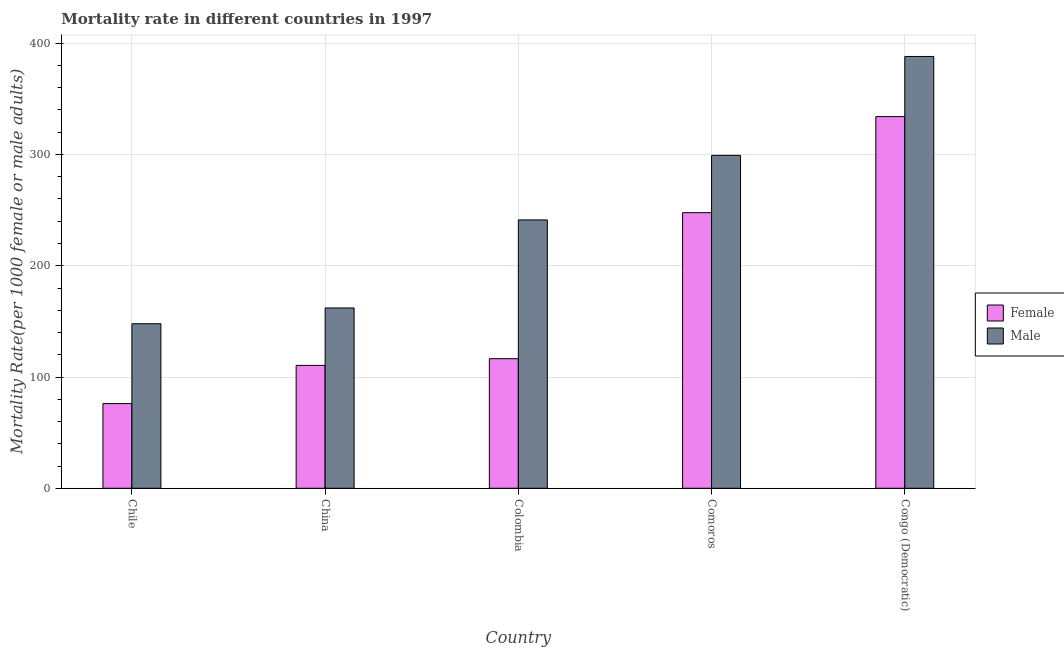How many groups of bars are there?
Give a very brief answer. 5. Are the number of bars on each tick of the X-axis equal?
Your answer should be compact. Yes. How many bars are there on the 2nd tick from the left?
Your answer should be compact. 2. How many bars are there on the 2nd tick from the right?
Offer a very short reply. 2. What is the label of the 5th group of bars from the left?
Your answer should be compact. Congo (Democratic). What is the female mortality rate in Congo (Democratic)?
Give a very brief answer. 334.06. Across all countries, what is the maximum male mortality rate?
Ensure brevity in your answer.  388.1. Across all countries, what is the minimum male mortality rate?
Offer a very short reply. 147.9. In which country was the male mortality rate maximum?
Ensure brevity in your answer.  Congo (Democratic). What is the total female mortality rate in the graph?
Your answer should be very brief. 884.8. What is the difference between the female mortality rate in Chile and that in Congo (Democratic)?
Offer a very short reply. -257.93. What is the difference between the male mortality rate in China and the female mortality rate in Congo (Democratic)?
Your answer should be compact. -172. What is the average male mortality rate per country?
Your response must be concise. 247.7. What is the difference between the female mortality rate and male mortality rate in Congo (Democratic)?
Keep it short and to the point. -54.04. What is the ratio of the male mortality rate in China to that in Colombia?
Make the answer very short. 0.67. What is the difference between the highest and the second highest female mortality rate?
Your answer should be very brief. 86.36. What is the difference between the highest and the lowest male mortality rate?
Provide a succinct answer. 240.2. Is the sum of the female mortality rate in China and Comoros greater than the maximum male mortality rate across all countries?
Make the answer very short. No. What does the 2nd bar from the right in Colombia represents?
Give a very brief answer. Female. How many countries are there in the graph?
Make the answer very short. 5. What is the difference between two consecutive major ticks on the Y-axis?
Offer a terse response. 100. Does the graph contain grids?
Offer a terse response. Yes. What is the title of the graph?
Keep it short and to the point. Mortality rate in different countries in 1997. What is the label or title of the X-axis?
Give a very brief answer. Country. What is the label or title of the Y-axis?
Keep it short and to the point. Mortality Rate(per 1000 female or male adults). What is the Mortality Rate(per 1000 female or male adults) of Female in Chile?
Provide a succinct answer. 76.13. What is the Mortality Rate(per 1000 female or male adults) of Male in Chile?
Your answer should be compact. 147.9. What is the Mortality Rate(per 1000 female or male adults) in Female in China?
Ensure brevity in your answer.  110.46. What is the Mortality Rate(per 1000 female or male adults) in Male in China?
Make the answer very short. 162.06. What is the Mortality Rate(per 1000 female or male adults) in Female in Colombia?
Provide a short and direct response. 116.47. What is the Mortality Rate(per 1000 female or male adults) of Male in Colombia?
Your answer should be compact. 241.19. What is the Mortality Rate(per 1000 female or male adults) of Female in Comoros?
Keep it short and to the point. 247.69. What is the Mortality Rate(per 1000 female or male adults) of Male in Comoros?
Your answer should be compact. 299.23. What is the Mortality Rate(per 1000 female or male adults) of Female in Congo (Democratic)?
Provide a succinct answer. 334.06. What is the Mortality Rate(per 1000 female or male adults) of Male in Congo (Democratic)?
Your answer should be very brief. 388.1. Across all countries, what is the maximum Mortality Rate(per 1000 female or male adults) of Female?
Your response must be concise. 334.06. Across all countries, what is the maximum Mortality Rate(per 1000 female or male adults) of Male?
Your answer should be very brief. 388.1. Across all countries, what is the minimum Mortality Rate(per 1000 female or male adults) in Female?
Make the answer very short. 76.13. Across all countries, what is the minimum Mortality Rate(per 1000 female or male adults) of Male?
Ensure brevity in your answer.  147.9. What is the total Mortality Rate(per 1000 female or male adults) in Female in the graph?
Provide a short and direct response. 884.8. What is the total Mortality Rate(per 1000 female or male adults) in Male in the graph?
Make the answer very short. 1238.48. What is the difference between the Mortality Rate(per 1000 female or male adults) in Female in Chile and that in China?
Your answer should be very brief. -34.33. What is the difference between the Mortality Rate(per 1000 female or male adults) in Male in Chile and that in China?
Your response must be concise. -14.16. What is the difference between the Mortality Rate(per 1000 female or male adults) of Female in Chile and that in Colombia?
Ensure brevity in your answer.  -40.34. What is the difference between the Mortality Rate(per 1000 female or male adults) in Male in Chile and that in Colombia?
Give a very brief answer. -93.3. What is the difference between the Mortality Rate(per 1000 female or male adults) of Female in Chile and that in Comoros?
Provide a succinct answer. -171.57. What is the difference between the Mortality Rate(per 1000 female or male adults) of Male in Chile and that in Comoros?
Keep it short and to the point. -151.33. What is the difference between the Mortality Rate(per 1000 female or male adults) of Female in Chile and that in Congo (Democratic)?
Your answer should be very brief. -257.93. What is the difference between the Mortality Rate(per 1000 female or male adults) of Male in Chile and that in Congo (Democratic)?
Ensure brevity in your answer.  -240.2. What is the difference between the Mortality Rate(per 1000 female or male adults) in Female in China and that in Colombia?
Keep it short and to the point. -6.01. What is the difference between the Mortality Rate(per 1000 female or male adults) of Male in China and that in Colombia?
Your answer should be very brief. -79.13. What is the difference between the Mortality Rate(per 1000 female or male adults) of Female in China and that in Comoros?
Keep it short and to the point. -137.24. What is the difference between the Mortality Rate(per 1000 female or male adults) of Male in China and that in Comoros?
Your answer should be compact. -137.16. What is the difference between the Mortality Rate(per 1000 female or male adults) in Female in China and that in Congo (Democratic)?
Give a very brief answer. -223.6. What is the difference between the Mortality Rate(per 1000 female or male adults) of Male in China and that in Congo (Democratic)?
Your response must be concise. -226.04. What is the difference between the Mortality Rate(per 1000 female or male adults) of Female in Colombia and that in Comoros?
Make the answer very short. -131.23. What is the difference between the Mortality Rate(per 1000 female or male adults) of Male in Colombia and that in Comoros?
Ensure brevity in your answer.  -58.03. What is the difference between the Mortality Rate(per 1000 female or male adults) in Female in Colombia and that in Congo (Democratic)?
Keep it short and to the point. -217.59. What is the difference between the Mortality Rate(per 1000 female or male adults) of Male in Colombia and that in Congo (Democratic)?
Your response must be concise. -146.91. What is the difference between the Mortality Rate(per 1000 female or male adults) in Female in Comoros and that in Congo (Democratic)?
Offer a terse response. -86.36. What is the difference between the Mortality Rate(per 1000 female or male adults) of Male in Comoros and that in Congo (Democratic)?
Make the answer very short. -88.88. What is the difference between the Mortality Rate(per 1000 female or male adults) in Female in Chile and the Mortality Rate(per 1000 female or male adults) in Male in China?
Make the answer very short. -85.94. What is the difference between the Mortality Rate(per 1000 female or male adults) of Female in Chile and the Mortality Rate(per 1000 female or male adults) of Male in Colombia?
Make the answer very short. -165.07. What is the difference between the Mortality Rate(per 1000 female or male adults) of Female in Chile and the Mortality Rate(per 1000 female or male adults) of Male in Comoros?
Your answer should be very brief. -223.1. What is the difference between the Mortality Rate(per 1000 female or male adults) in Female in Chile and the Mortality Rate(per 1000 female or male adults) in Male in Congo (Democratic)?
Make the answer very short. -311.97. What is the difference between the Mortality Rate(per 1000 female or male adults) in Female in China and the Mortality Rate(per 1000 female or male adults) in Male in Colombia?
Provide a short and direct response. -130.74. What is the difference between the Mortality Rate(per 1000 female or male adults) in Female in China and the Mortality Rate(per 1000 female or male adults) in Male in Comoros?
Provide a short and direct response. -188.77. What is the difference between the Mortality Rate(per 1000 female or male adults) of Female in China and the Mortality Rate(per 1000 female or male adults) of Male in Congo (Democratic)?
Your response must be concise. -277.64. What is the difference between the Mortality Rate(per 1000 female or male adults) in Female in Colombia and the Mortality Rate(per 1000 female or male adults) in Male in Comoros?
Give a very brief answer. -182.76. What is the difference between the Mortality Rate(per 1000 female or male adults) in Female in Colombia and the Mortality Rate(per 1000 female or male adults) in Male in Congo (Democratic)?
Your answer should be very brief. -271.64. What is the difference between the Mortality Rate(per 1000 female or male adults) in Female in Comoros and the Mortality Rate(per 1000 female or male adults) in Male in Congo (Democratic)?
Provide a succinct answer. -140.41. What is the average Mortality Rate(per 1000 female or male adults) of Female per country?
Provide a succinct answer. 176.96. What is the average Mortality Rate(per 1000 female or male adults) of Male per country?
Make the answer very short. 247.7. What is the difference between the Mortality Rate(per 1000 female or male adults) of Female and Mortality Rate(per 1000 female or male adults) of Male in Chile?
Offer a terse response. -71.77. What is the difference between the Mortality Rate(per 1000 female or male adults) in Female and Mortality Rate(per 1000 female or male adults) in Male in China?
Offer a very short reply. -51.6. What is the difference between the Mortality Rate(per 1000 female or male adults) in Female and Mortality Rate(per 1000 female or male adults) in Male in Colombia?
Give a very brief answer. -124.73. What is the difference between the Mortality Rate(per 1000 female or male adults) in Female and Mortality Rate(per 1000 female or male adults) in Male in Comoros?
Give a very brief answer. -51.53. What is the difference between the Mortality Rate(per 1000 female or male adults) of Female and Mortality Rate(per 1000 female or male adults) of Male in Congo (Democratic)?
Your response must be concise. -54.04. What is the ratio of the Mortality Rate(per 1000 female or male adults) in Female in Chile to that in China?
Make the answer very short. 0.69. What is the ratio of the Mortality Rate(per 1000 female or male adults) of Male in Chile to that in China?
Keep it short and to the point. 0.91. What is the ratio of the Mortality Rate(per 1000 female or male adults) of Female in Chile to that in Colombia?
Keep it short and to the point. 0.65. What is the ratio of the Mortality Rate(per 1000 female or male adults) in Male in Chile to that in Colombia?
Offer a very short reply. 0.61. What is the ratio of the Mortality Rate(per 1000 female or male adults) in Female in Chile to that in Comoros?
Give a very brief answer. 0.31. What is the ratio of the Mortality Rate(per 1000 female or male adults) in Male in Chile to that in Comoros?
Your response must be concise. 0.49. What is the ratio of the Mortality Rate(per 1000 female or male adults) of Female in Chile to that in Congo (Democratic)?
Offer a very short reply. 0.23. What is the ratio of the Mortality Rate(per 1000 female or male adults) of Male in Chile to that in Congo (Democratic)?
Provide a short and direct response. 0.38. What is the ratio of the Mortality Rate(per 1000 female or male adults) of Female in China to that in Colombia?
Offer a terse response. 0.95. What is the ratio of the Mortality Rate(per 1000 female or male adults) of Male in China to that in Colombia?
Ensure brevity in your answer.  0.67. What is the ratio of the Mortality Rate(per 1000 female or male adults) in Female in China to that in Comoros?
Keep it short and to the point. 0.45. What is the ratio of the Mortality Rate(per 1000 female or male adults) in Male in China to that in Comoros?
Your answer should be very brief. 0.54. What is the ratio of the Mortality Rate(per 1000 female or male adults) in Female in China to that in Congo (Democratic)?
Give a very brief answer. 0.33. What is the ratio of the Mortality Rate(per 1000 female or male adults) of Male in China to that in Congo (Democratic)?
Your response must be concise. 0.42. What is the ratio of the Mortality Rate(per 1000 female or male adults) in Female in Colombia to that in Comoros?
Make the answer very short. 0.47. What is the ratio of the Mortality Rate(per 1000 female or male adults) of Male in Colombia to that in Comoros?
Your answer should be very brief. 0.81. What is the ratio of the Mortality Rate(per 1000 female or male adults) of Female in Colombia to that in Congo (Democratic)?
Offer a terse response. 0.35. What is the ratio of the Mortality Rate(per 1000 female or male adults) in Male in Colombia to that in Congo (Democratic)?
Keep it short and to the point. 0.62. What is the ratio of the Mortality Rate(per 1000 female or male adults) of Female in Comoros to that in Congo (Democratic)?
Your answer should be very brief. 0.74. What is the ratio of the Mortality Rate(per 1000 female or male adults) of Male in Comoros to that in Congo (Democratic)?
Keep it short and to the point. 0.77. What is the difference between the highest and the second highest Mortality Rate(per 1000 female or male adults) of Female?
Provide a succinct answer. 86.36. What is the difference between the highest and the second highest Mortality Rate(per 1000 female or male adults) in Male?
Make the answer very short. 88.88. What is the difference between the highest and the lowest Mortality Rate(per 1000 female or male adults) of Female?
Offer a terse response. 257.93. What is the difference between the highest and the lowest Mortality Rate(per 1000 female or male adults) in Male?
Make the answer very short. 240.2. 